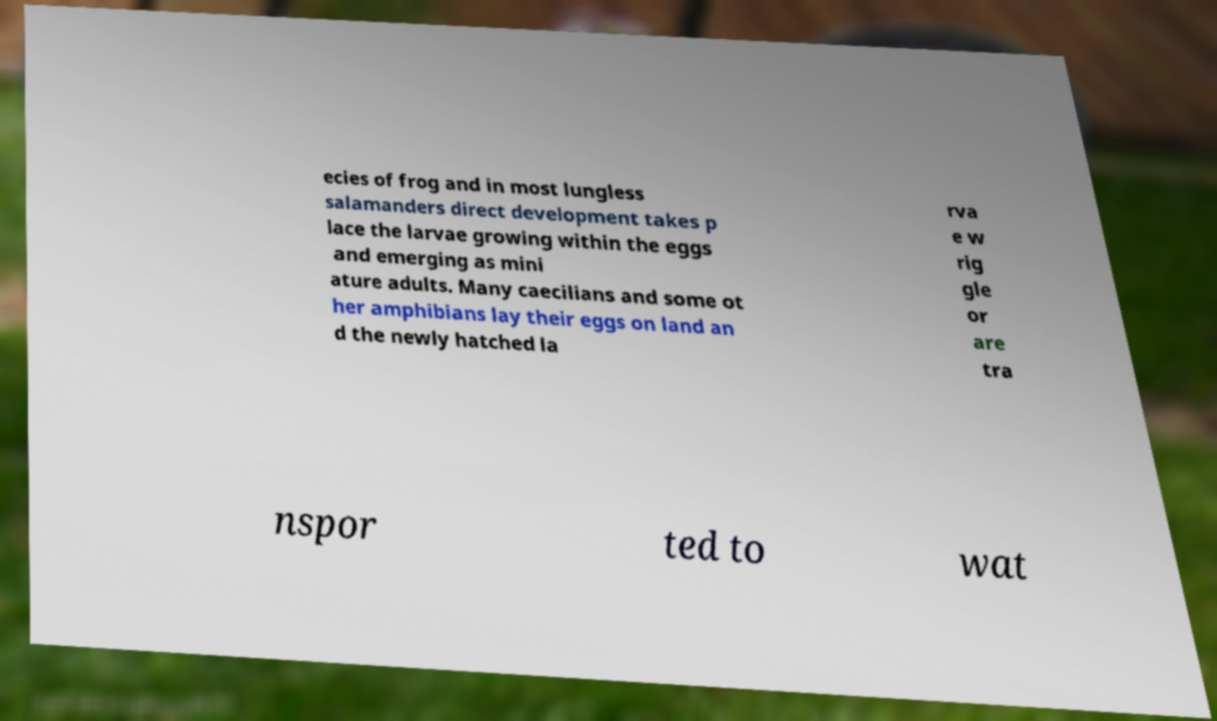Please identify and transcribe the text found in this image. ecies of frog and in most lungless salamanders direct development takes p lace the larvae growing within the eggs and emerging as mini ature adults. Many caecilians and some ot her amphibians lay their eggs on land an d the newly hatched la rva e w rig gle or are tra nspor ted to wat 